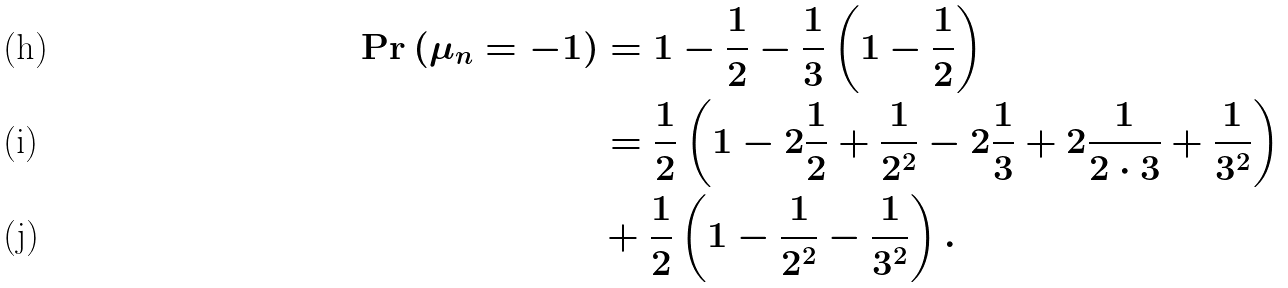Convert formula to latex. <formula><loc_0><loc_0><loc_500><loc_500>\Pr \left ( \mu _ { n } = - 1 \right ) & = 1 - \frac { 1 } { 2 } - \frac { 1 } { 3 } \left ( 1 - \frac { 1 } { 2 } \right ) \\ & = \frac { 1 } { 2 } \left ( 1 - 2 \frac { 1 } { 2 } + \frac { 1 } { 2 ^ { 2 } } - 2 \frac { 1 } { 3 } + 2 \frac { 1 } { 2 \cdot 3 } + \frac { 1 } { 3 ^ { 2 } } \right ) \\ & + \frac { 1 } { 2 } \left ( 1 - \frac { 1 } { 2 ^ { 2 } } - \frac { 1 } { 3 ^ { 2 } } \right ) .</formula> 